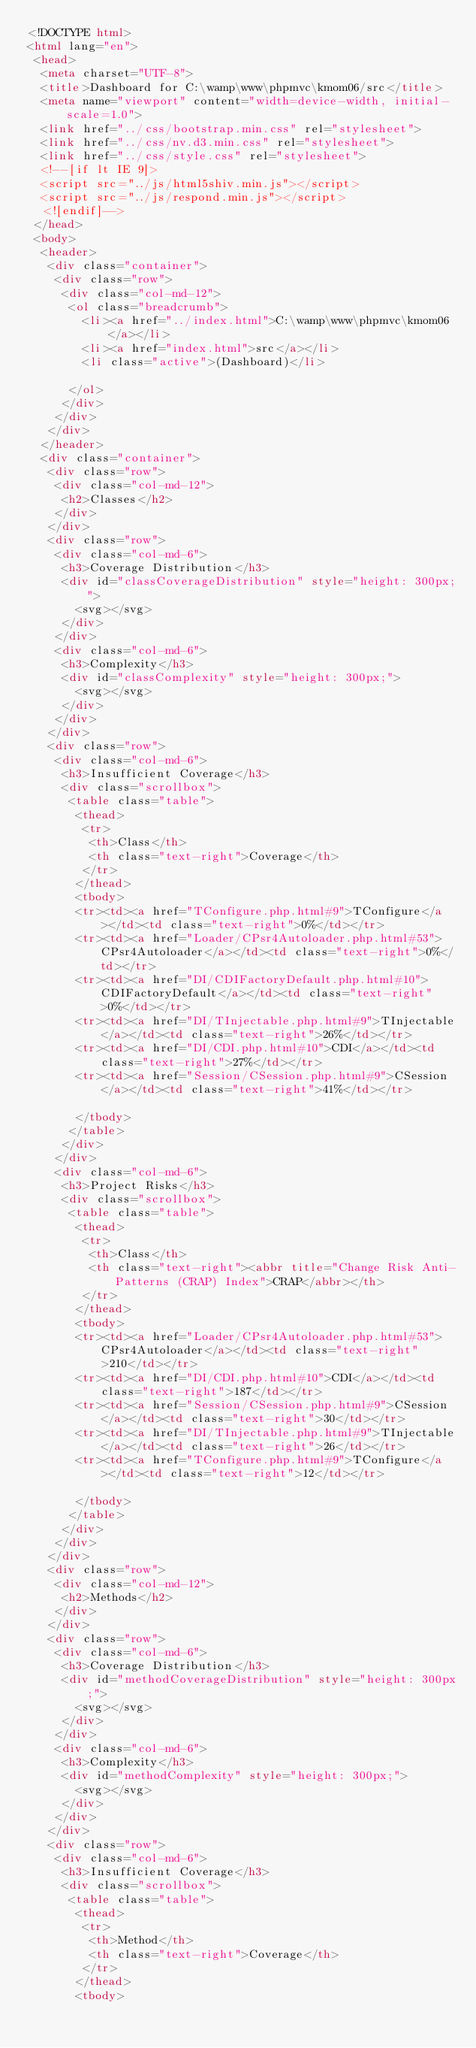Convert code to text. <code><loc_0><loc_0><loc_500><loc_500><_HTML_><!DOCTYPE html>
<html lang="en">
 <head>
  <meta charset="UTF-8">
  <title>Dashboard for C:\wamp\www\phpmvc\kmom06/src</title>
  <meta name="viewport" content="width=device-width, initial-scale=1.0">
  <link href="../css/bootstrap.min.css" rel="stylesheet">
  <link href="../css/nv.d3.min.css" rel="stylesheet">
  <link href="../css/style.css" rel="stylesheet">
  <!--[if lt IE 9]>
  <script src="../js/html5shiv.min.js"></script>
  <script src="../js/respond.min.js"></script>
  <![endif]-->
 </head>
 <body>
  <header>
   <div class="container">
    <div class="row">
     <div class="col-md-12">
      <ol class="breadcrumb">
        <li><a href="../index.html">C:\wamp\www\phpmvc\kmom06</a></li>
        <li><a href="index.html">src</a></li>
        <li class="active">(Dashboard)</li>

      </ol>
     </div>
    </div>
   </div>
  </header>
  <div class="container">
   <div class="row">
    <div class="col-md-12">
     <h2>Classes</h2>
    </div>
   </div>
   <div class="row">
    <div class="col-md-6">
     <h3>Coverage Distribution</h3>
     <div id="classCoverageDistribution" style="height: 300px;">
       <svg></svg>
     </div>
    </div>
    <div class="col-md-6">
     <h3>Complexity</h3>
     <div id="classComplexity" style="height: 300px;">
       <svg></svg>
     </div>
    </div>
   </div>
   <div class="row">
    <div class="col-md-6">
     <h3>Insufficient Coverage</h3>
     <div class="scrollbox">
      <table class="table">
       <thead>
        <tr>
         <th>Class</th>
         <th class="text-right">Coverage</th>
        </tr>
       </thead>
       <tbody>
       <tr><td><a href="TConfigure.php.html#9">TConfigure</a></td><td class="text-right">0%</td></tr>
       <tr><td><a href="Loader/CPsr4Autoloader.php.html#53">CPsr4Autoloader</a></td><td class="text-right">0%</td></tr>
       <tr><td><a href="DI/CDIFactoryDefault.php.html#10">CDIFactoryDefault</a></td><td class="text-right">0%</td></tr>
       <tr><td><a href="DI/TInjectable.php.html#9">TInjectable</a></td><td class="text-right">26%</td></tr>
       <tr><td><a href="DI/CDI.php.html#10">CDI</a></td><td class="text-right">27%</td></tr>
       <tr><td><a href="Session/CSession.php.html#9">CSession</a></td><td class="text-right">41%</td></tr>

       </tbody>
      </table>
     </div>
    </div>
    <div class="col-md-6">
     <h3>Project Risks</h3>
     <div class="scrollbox">
      <table class="table">
       <thead>
        <tr>
         <th>Class</th>
         <th class="text-right"><abbr title="Change Risk Anti-Patterns (CRAP) Index">CRAP</abbr></th>
        </tr>
       </thead>
       <tbody>
       <tr><td><a href="Loader/CPsr4Autoloader.php.html#53">CPsr4Autoloader</a></td><td class="text-right">210</td></tr>
       <tr><td><a href="DI/CDI.php.html#10">CDI</a></td><td class="text-right">187</td></tr>
       <tr><td><a href="Session/CSession.php.html#9">CSession</a></td><td class="text-right">30</td></tr>
       <tr><td><a href="DI/TInjectable.php.html#9">TInjectable</a></td><td class="text-right">26</td></tr>
       <tr><td><a href="TConfigure.php.html#9">TConfigure</a></td><td class="text-right">12</td></tr>

       </tbody>
      </table>
     </div>
    </div>
   </div>
   <div class="row">
    <div class="col-md-12">
     <h2>Methods</h2>
    </div>
   </div>
   <div class="row">
    <div class="col-md-6">
     <h3>Coverage Distribution</h3>
     <div id="methodCoverageDistribution" style="height: 300px;">
       <svg></svg>
     </div>
    </div>
    <div class="col-md-6">
     <h3>Complexity</h3>
     <div id="methodComplexity" style="height: 300px;">
       <svg></svg>
     </div>
    </div>
   </div>
   <div class="row">
    <div class="col-md-6">
     <h3>Insufficient Coverage</h3>
     <div class="scrollbox">
      <table class="table">
       <thead>
        <tr>
         <th>Method</th>
         <th class="text-right">Coverage</th>
        </tr>
       </thead>
       <tbody></code> 